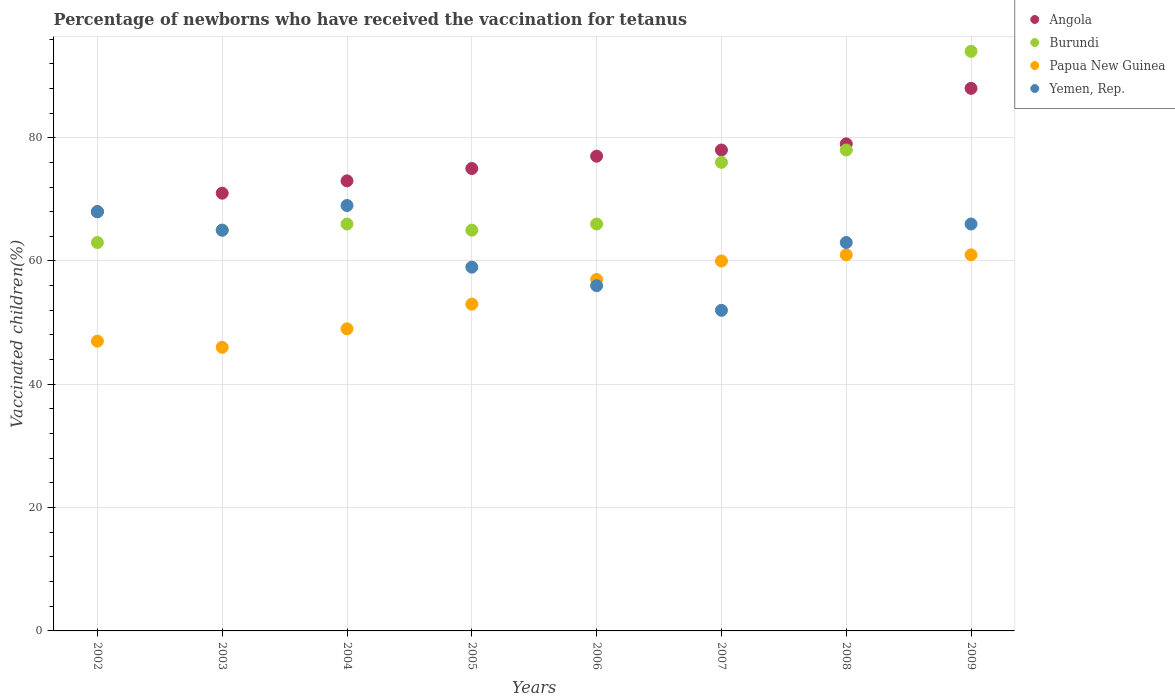Is the number of dotlines equal to the number of legend labels?
Provide a short and direct response. Yes. What is the percentage of vaccinated children in Papua New Guinea in 2006?
Provide a short and direct response. 57. Across all years, what is the maximum percentage of vaccinated children in Yemen, Rep.?
Ensure brevity in your answer.  69. Across all years, what is the minimum percentage of vaccinated children in Papua New Guinea?
Offer a very short reply. 46. What is the total percentage of vaccinated children in Yemen, Rep. in the graph?
Offer a terse response. 498. What is the difference between the percentage of vaccinated children in Angola in 2003 and that in 2004?
Make the answer very short. -2. What is the average percentage of vaccinated children in Burundi per year?
Provide a succinct answer. 71.62. In how many years, is the percentage of vaccinated children in Papua New Guinea greater than 4 %?
Provide a succinct answer. 8. What is the ratio of the percentage of vaccinated children in Angola in 2002 to that in 2008?
Ensure brevity in your answer.  0.86. Is the percentage of vaccinated children in Angola in 2003 less than that in 2004?
Provide a succinct answer. Yes. In how many years, is the percentage of vaccinated children in Burundi greater than the average percentage of vaccinated children in Burundi taken over all years?
Make the answer very short. 3. Is it the case that in every year, the sum of the percentage of vaccinated children in Papua New Guinea and percentage of vaccinated children in Yemen, Rep.  is greater than the sum of percentage of vaccinated children in Angola and percentage of vaccinated children in Burundi?
Keep it short and to the point. No. Is the percentage of vaccinated children in Burundi strictly greater than the percentage of vaccinated children in Angola over the years?
Provide a succinct answer. No. How many dotlines are there?
Offer a terse response. 4. Are the values on the major ticks of Y-axis written in scientific E-notation?
Give a very brief answer. No. Does the graph contain any zero values?
Your response must be concise. No. Does the graph contain grids?
Give a very brief answer. Yes. Where does the legend appear in the graph?
Keep it short and to the point. Top right. How are the legend labels stacked?
Your answer should be very brief. Vertical. What is the title of the graph?
Ensure brevity in your answer.  Percentage of newborns who have received the vaccination for tetanus. What is the label or title of the Y-axis?
Provide a short and direct response. Vaccinated children(%). What is the Vaccinated children(%) of Burundi in 2002?
Ensure brevity in your answer.  63. What is the Vaccinated children(%) of Yemen, Rep. in 2002?
Provide a short and direct response. 68. What is the Vaccinated children(%) in Angola in 2003?
Your answer should be compact. 71. What is the Vaccinated children(%) in Yemen, Rep. in 2003?
Keep it short and to the point. 65. What is the Vaccinated children(%) of Angola in 2004?
Ensure brevity in your answer.  73. What is the Vaccinated children(%) in Yemen, Rep. in 2004?
Offer a very short reply. 69. What is the Vaccinated children(%) in Burundi in 2005?
Provide a succinct answer. 65. What is the Vaccinated children(%) of Papua New Guinea in 2005?
Keep it short and to the point. 53. What is the Vaccinated children(%) in Yemen, Rep. in 2005?
Make the answer very short. 59. What is the Vaccinated children(%) of Burundi in 2006?
Offer a terse response. 66. What is the Vaccinated children(%) in Papua New Guinea in 2006?
Offer a terse response. 57. What is the Vaccinated children(%) of Angola in 2007?
Your answer should be compact. 78. What is the Vaccinated children(%) in Burundi in 2007?
Ensure brevity in your answer.  76. What is the Vaccinated children(%) in Yemen, Rep. in 2007?
Offer a very short reply. 52. What is the Vaccinated children(%) of Angola in 2008?
Ensure brevity in your answer.  79. What is the Vaccinated children(%) in Burundi in 2008?
Give a very brief answer. 78. What is the Vaccinated children(%) of Burundi in 2009?
Keep it short and to the point. 94. What is the Vaccinated children(%) of Papua New Guinea in 2009?
Your response must be concise. 61. Across all years, what is the maximum Vaccinated children(%) in Burundi?
Provide a short and direct response. 94. Across all years, what is the maximum Vaccinated children(%) of Papua New Guinea?
Your response must be concise. 61. Across all years, what is the minimum Vaccinated children(%) of Burundi?
Offer a very short reply. 63. Across all years, what is the minimum Vaccinated children(%) in Yemen, Rep.?
Offer a very short reply. 52. What is the total Vaccinated children(%) in Angola in the graph?
Keep it short and to the point. 609. What is the total Vaccinated children(%) of Burundi in the graph?
Offer a terse response. 573. What is the total Vaccinated children(%) in Papua New Guinea in the graph?
Your answer should be very brief. 434. What is the total Vaccinated children(%) of Yemen, Rep. in the graph?
Offer a very short reply. 498. What is the difference between the Vaccinated children(%) of Angola in 2002 and that in 2003?
Offer a very short reply. -3. What is the difference between the Vaccinated children(%) of Angola in 2002 and that in 2004?
Your answer should be very brief. -5. What is the difference between the Vaccinated children(%) of Burundi in 2002 and that in 2004?
Your answer should be compact. -3. What is the difference between the Vaccinated children(%) of Papua New Guinea in 2002 and that in 2005?
Your answer should be very brief. -6. What is the difference between the Vaccinated children(%) of Papua New Guinea in 2002 and that in 2006?
Your response must be concise. -10. What is the difference between the Vaccinated children(%) of Yemen, Rep. in 2002 and that in 2006?
Offer a very short reply. 12. What is the difference between the Vaccinated children(%) of Angola in 2002 and that in 2007?
Make the answer very short. -10. What is the difference between the Vaccinated children(%) of Papua New Guinea in 2002 and that in 2007?
Ensure brevity in your answer.  -13. What is the difference between the Vaccinated children(%) of Angola in 2002 and that in 2008?
Your response must be concise. -11. What is the difference between the Vaccinated children(%) of Angola in 2002 and that in 2009?
Make the answer very short. -20. What is the difference between the Vaccinated children(%) of Burundi in 2002 and that in 2009?
Keep it short and to the point. -31. What is the difference between the Vaccinated children(%) in Papua New Guinea in 2002 and that in 2009?
Provide a succinct answer. -14. What is the difference between the Vaccinated children(%) in Burundi in 2003 and that in 2004?
Keep it short and to the point. -1. What is the difference between the Vaccinated children(%) of Papua New Guinea in 2003 and that in 2004?
Make the answer very short. -3. What is the difference between the Vaccinated children(%) in Burundi in 2003 and that in 2005?
Give a very brief answer. 0. What is the difference between the Vaccinated children(%) of Yemen, Rep. in 2003 and that in 2005?
Ensure brevity in your answer.  6. What is the difference between the Vaccinated children(%) of Angola in 2003 and that in 2006?
Make the answer very short. -6. What is the difference between the Vaccinated children(%) of Burundi in 2003 and that in 2007?
Ensure brevity in your answer.  -11. What is the difference between the Vaccinated children(%) of Yemen, Rep. in 2003 and that in 2007?
Keep it short and to the point. 13. What is the difference between the Vaccinated children(%) in Angola in 2003 and that in 2008?
Your response must be concise. -8. What is the difference between the Vaccinated children(%) in Burundi in 2003 and that in 2008?
Your response must be concise. -13. What is the difference between the Vaccinated children(%) of Yemen, Rep. in 2003 and that in 2008?
Your response must be concise. 2. What is the difference between the Vaccinated children(%) in Angola in 2004 and that in 2005?
Your answer should be very brief. -2. What is the difference between the Vaccinated children(%) of Burundi in 2004 and that in 2005?
Your answer should be compact. 1. What is the difference between the Vaccinated children(%) of Angola in 2004 and that in 2006?
Your answer should be compact. -4. What is the difference between the Vaccinated children(%) of Burundi in 2004 and that in 2006?
Provide a succinct answer. 0. What is the difference between the Vaccinated children(%) of Papua New Guinea in 2004 and that in 2006?
Your answer should be very brief. -8. What is the difference between the Vaccinated children(%) of Yemen, Rep. in 2004 and that in 2006?
Your answer should be very brief. 13. What is the difference between the Vaccinated children(%) of Papua New Guinea in 2004 and that in 2007?
Your answer should be very brief. -11. What is the difference between the Vaccinated children(%) in Yemen, Rep. in 2004 and that in 2007?
Provide a short and direct response. 17. What is the difference between the Vaccinated children(%) of Angola in 2004 and that in 2008?
Your answer should be very brief. -6. What is the difference between the Vaccinated children(%) in Burundi in 2004 and that in 2009?
Ensure brevity in your answer.  -28. What is the difference between the Vaccinated children(%) of Angola in 2005 and that in 2006?
Offer a very short reply. -2. What is the difference between the Vaccinated children(%) of Burundi in 2005 and that in 2006?
Provide a succinct answer. -1. What is the difference between the Vaccinated children(%) of Papua New Guinea in 2005 and that in 2006?
Your answer should be compact. -4. What is the difference between the Vaccinated children(%) in Yemen, Rep. in 2005 and that in 2006?
Your response must be concise. 3. What is the difference between the Vaccinated children(%) of Angola in 2005 and that in 2007?
Provide a short and direct response. -3. What is the difference between the Vaccinated children(%) of Papua New Guinea in 2005 and that in 2007?
Your answer should be compact. -7. What is the difference between the Vaccinated children(%) in Yemen, Rep. in 2005 and that in 2007?
Make the answer very short. 7. What is the difference between the Vaccinated children(%) of Papua New Guinea in 2005 and that in 2009?
Your answer should be compact. -8. What is the difference between the Vaccinated children(%) in Burundi in 2006 and that in 2007?
Your answer should be very brief. -10. What is the difference between the Vaccinated children(%) in Papua New Guinea in 2006 and that in 2007?
Offer a terse response. -3. What is the difference between the Vaccinated children(%) in Yemen, Rep. in 2006 and that in 2007?
Your answer should be very brief. 4. What is the difference between the Vaccinated children(%) of Papua New Guinea in 2006 and that in 2009?
Give a very brief answer. -4. What is the difference between the Vaccinated children(%) of Yemen, Rep. in 2006 and that in 2009?
Provide a short and direct response. -10. What is the difference between the Vaccinated children(%) of Angola in 2007 and that in 2008?
Make the answer very short. -1. What is the difference between the Vaccinated children(%) in Burundi in 2007 and that in 2008?
Provide a succinct answer. -2. What is the difference between the Vaccinated children(%) in Papua New Guinea in 2007 and that in 2008?
Your answer should be compact. -1. What is the difference between the Vaccinated children(%) of Yemen, Rep. in 2007 and that in 2008?
Give a very brief answer. -11. What is the difference between the Vaccinated children(%) in Burundi in 2007 and that in 2009?
Your answer should be very brief. -18. What is the difference between the Vaccinated children(%) in Papua New Guinea in 2007 and that in 2009?
Offer a very short reply. -1. What is the difference between the Vaccinated children(%) in Burundi in 2008 and that in 2009?
Offer a very short reply. -16. What is the difference between the Vaccinated children(%) in Yemen, Rep. in 2008 and that in 2009?
Give a very brief answer. -3. What is the difference between the Vaccinated children(%) of Angola in 2002 and the Vaccinated children(%) of Burundi in 2003?
Offer a very short reply. 3. What is the difference between the Vaccinated children(%) of Angola in 2002 and the Vaccinated children(%) of Papua New Guinea in 2003?
Make the answer very short. 22. What is the difference between the Vaccinated children(%) of Angola in 2002 and the Vaccinated children(%) of Yemen, Rep. in 2003?
Give a very brief answer. 3. What is the difference between the Vaccinated children(%) of Angola in 2002 and the Vaccinated children(%) of Burundi in 2004?
Your answer should be compact. 2. What is the difference between the Vaccinated children(%) of Angola in 2002 and the Vaccinated children(%) of Papua New Guinea in 2004?
Make the answer very short. 19. What is the difference between the Vaccinated children(%) in Burundi in 2002 and the Vaccinated children(%) in Yemen, Rep. in 2004?
Provide a succinct answer. -6. What is the difference between the Vaccinated children(%) in Angola in 2002 and the Vaccinated children(%) in Burundi in 2005?
Your response must be concise. 3. What is the difference between the Vaccinated children(%) in Angola in 2002 and the Vaccinated children(%) in Papua New Guinea in 2005?
Provide a short and direct response. 15. What is the difference between the Vaccinated children(%) in Angola in 2002 and the Vaccinated children(%) in Burundi in 2006?
Provide a succinct answer. 2. What is the difference between the Vaccinated children(%) in Angola in 2002 and the Vaccinated children(%) in Papua New Guinea in 2006?
Provide a succinct answer. 11. What is the difference between the Vaccinated children(%) of Angola in 2002 and the Vaccinated children(%) of Yemen, Rep. in 2006?
Your answer should be very brief. 12. What is the difference between the Vaccinated children(%) of Burundi in 2002 and the Vaccinated children(%) of Papua New Guinea in 2006?
Give a very brief answer. 6. What is the difference between the Vaccinated children(%) of Angola in 2002 and the Vaccinated children(%) of Burundi in 2007?
Make the answer very short. -8. What is the difference between the Vaccinated children(%) in Burundi in 2002 and the Vaccinated children(%) in Papua New Guinea in 2007?
Make the answer very short. 3. What is the difference between the Vaccinated children(%) in Burundi in 2002 and the Vaccinated children(%) in Yemen, Rep. in 2007?
Offer a terse response. 11. What is the difference between the Vaccinated children(%) in Papua New Guinea in 2002 and the Vaccinated children(%) in Yemen, Rep. in 2007?
Keep it short and to the point. -5. What is the difference between the Vaccinated children(%) of Angola in 2002 and the Vaccinated children(%) of Papua New Guinea in 2008?
Your answer should be very brief. 7. What is the difference between the Vaccinated children(%) in Angola in 2002 and the Vaccinated children(%) in Yemen, Rep. in 2008?
Make the answer very short. 5. What is the difference between the Vaccinated children(%) in Burundi in 2002 and the Vaccinated children(%) in Yemen, Rep. in 2008?
Provide a succinct answer. 0. What is the difference between the Vaccinated children(%) of Angola in 2002 and the Vaccinated children(%) of Burundi in 2009?
Provide a short and direct response. -26. What is the difference between the Vaccinated children(%) in Angola in 2002 and the Vaccinated children(%) in Yemen, Rep. in 2009?
Your answer should be compact. 2. What is the difference between the Vaccinated children(%) in Papua New Guinea in 2002 and the Vaccinated children(%) in Yemen, Rep. in 2009?
Ensure brevity in your answer.  -19. What is the difference between the Vaccinated children(%) in Angola in 2003 and the Vaccinated children(%) in Burundi in 2004?
Your answer should be very brief. 5. What is the difference between the Vaccinated children(%) in Burundi in 2003 and the Vaccinated children(%) in Papua New Guinea in 2004?
Give a very brief answer. 16. What is the difference between the Vaccinated children(%) in Angola in 2003 and the Vaccinated children(%) in Yemen, Rep. in 2005?
Your answer should be compact. 12. What is the difference between the Vaccinated children(%) of Angola in 2003 and the Vaccinated children(%) of Burundi in 2006?
Your answer should be very brief. 5. What is the difference between the Vaccinated children(%) of Angola in 2003 and the Vaccinated children(%) of Papua New Guinea in 2006?
Provide a short and direct response. 14. What is the difference between the Vaccinated children(%) in Angola in 2003 and the Vaccinated children(%) in Yemen, Rep. in 2006?
Provide a succinct answer. 15. What is the difference between the Vaccinated children(%) in Burundi in 2003 and the Vaccinated children(%) in Papua New Guinea in 2006?
Keep it short and to the point. 8. What is the difference between the Vaccinated children(%) of Burundi in 2003 and the Vaccinated children(%) of Yemen, Rep. in 2006?
Your answer should be very brief. 9. What is the difference between the Vaccinated children(%) in Papua New Guinea in 2003 and the Vaccinated children(%) in Yemen, Rep. in 2006?
Offer a very short reply. -10. What is the difference between the Vaccinated children(%) of Angola in 2003 and the Vaccinated children(%) of Burundi in 2007?
Your response must be concise. -5. What is the difference between the Vaccinated children(%) of Angola in 2003 and the Vaccinated children(%) of Burundi in 2008?
Ensure brevity in your answer.  -7. What is the difference between the Vaccinated children(%) of Angola in 2003 and the Vaccinated children(%) of Yemen, Rep. in 2008?
Offer a very short reply. 8. What is the difference between the Vaccinated children(%) in Burundi in 2003 and the Vaccinated children(%) in Papua New Guinea in 2008?
Your answer should be compact. 4. What is the difference between the Vaccinated children(%) of Angola in 2003 and the Vaccinated children(%) of Burundi in 2009?
Keep it short and to the point. -23. What is the difference between the Vaccinated children(%) of Angola in 2003 and the Vaccinated children(%) of Papua New Guinea in 2009?
Give a very brief answer. 10. What is the difference between the Vaccinated children(%) in Angola in 2003 and the Vaccinated children(%) in Yemen, Rep. in 2009?
Your response must be concise. 5. What is the difference between the Vaccinated children(%) in Burundi in 2003 and the Vaccinated children(%) in Papua New Guinea in 2009?
Ensure brevity in your answer.  4. What is the difference between the Vaccinated children(%) of Burundi in 2003 and the Vaccinated children(%) of Yemen, Rep. in 2009?
Provide a short and direct response. -1. What is the difference between the Vaccinated children(%) in Angola in 2004 and the Vaccinated children(%) in Papua New Guinea in 2005?
Give a very brief answer. 20. What is the difference between the Vaccinated children(%) in Burundi in 2004 and the Vaccinated children(%) in Papua New Guinea in 2005?
Offer a very short reply. 13. What is the difference between the Vaccinated children(%) of Angola in 2004 and the Vaccinated children(%) of Burundi in 2006?
Ensure brevity in your answer.  7. What is the difference between the Vaccinated children(%) in Angola in 2004 and the Vaccinated children(%) in Papua New Guinea in 2006?
Your answer should be very brief. 16. What is the difference between the Vaccinated children(%) in Angola in 2004 and the Vaccinated children(%) in Yemen, Rep. in 2006?
Make the answer very short. 17. What is the difference between the Vaccinated children(%) in Burundi in 2004 and the Vaccinated children(%) in Papua New Guinea in 2006?
Your answer should be very brief. 9. What is the difference between the Vaccinated children(%) in Papua New Guinea in 2004 and the Vaccinated children(%) in Yemen, Rep. in 2006?
Ensure brevity in your answer.  -7. What is the difference between the Vaccinated children(%) in Angola in 2004 and the Vaccinated children(%) in Yemen, Rep. in 2007?
Provide a short and direct response. 21. What is the difference between the Vaccinated children(%) of Burundi in 2004 and the Vaccinated children(%) of Papua New Guinea in 2007?
Keep it short and to the point. 6. What is the difference between the Vaccinated children(%) in Angola in 2004 and the Vaccinated children(%) in Burundi in 2008?
Give a very brief answer. -5. What is the difference between the Vaccinated children(%) of Angola in 2004 and the Vaccinated children(%) of Papua New Guinea in 2008?
Keep it short and to the point. 12. What is the difference between the Vaccinated children(%) in Burundi in 2004 and the Vaccinated children(%) in Papua New Guinea in 2008?
Your answer should be very brief. 5. What is the difference between the Vaccinated children(%) of Angola in 2004 and the Vaccinated children(%) of Burundi in 2009?
Give a very brief answer. -21. What is the difference between the Vaccinated children(%) of Angola in 2004 and the Vaccinated children(%) of Papua New Guinea in 2009?
Your answer should be very brief. 12. What is the difference between the Vaccinated children(%) in Papua New Guinea in 2004 and the Vaccinated children(%) in Yemen, Rep. in 2009?
Your response must be concise. -17. What is the difference between the Vaccinated children(%) in Angola in 2005 and the Vaccinated children(%) in Burundi in 2006?
Ensure brevity in your answer.  9. What is the difference between the Vaccinated children(%) in Angola in 2005 and the Vaccinated children(%) in Yemen, Rep. in 2006?
Provide a short and direct response. 19. What is the difference between the Vaccinated children(%) of Burundi in 2005 and the Vaccinated children(%) of Papua New Guinea in 2006?
Ensure brevity in your answer.  8. What is the difference between the Vaccinated children(%) in Burundi in 2005 and the Vaccinated children(%) in Yemen, Rep. in 2006?
Give a very brief answer. 9. What is the difference between the Vaccinated children(%) in Papua New Guinea in 2005 and the Vaccinated children(%) in Yemen, Rep. in 2006?
Make the answer very short. -3. What is the difference between the Vaccinated children(%) in Angola in 2005 and the Vaccinated children(%) in Yemen, Rep. in 2007?
Give a very brief answer. 23. What is the difference between the Vaccinated children(%) in Burundi in 2005 and the Vaccinated children(%) in Papua New Guinea in 2007?
Your response must be concise. 5. What is the difference between the Vaccinated children(%) in Angola in 2005 and the Vaccinated children(%) in Burundi in 2008?
Make the answer very short. -3. What is the difference between the Vaccinated children(%) of Angola in 2005 and the Vaccinated children(%) of Papua New Guinea in 2008?
Give a very brief answer. 14. What is the difference between the Vaccinated children(%) in Burundi in 2005 and the Vaccinated children(%) in Yemen, Rep. in 2008?
Your response must be concise. 2. What is the difference between the Vaccinated children(%) in Burundi in 2005 and the Vaccinated children(%) in Yemen, Rep. in 2009?
Your answer should be very brief. -1. What is the difference between the Vaccinated children(%) in Angola in 2006 and the Vaccinated children(%) in Burundi in 2007?
Make the answer very short. 1. What is the difference between the Vaccinated children(%) of Angola in 2006 and the Vaccinated children(%) of Papua New Guinea in 2007?
Provide a short and direct response. 17. What is the difference between the Vaccinated children(%) in Burundi in 2006 and the Vaccinated children(%) in Yemen, Rep. in 2007?
Offer a terse response. 14. What is the difference between the Vaccinated children(%) of Angola in 2006 and the Vaccinated children(%) of Yemen, Rep. in 2009?
Give a very brief answer. 11. What is the difference between the Vaccinated children(%) in Angola in 2007 and the Vaccinated children(%) in Burundi in 2008?
Make the answer very short. 0. What is the difference between the Vaccinated children(%) of Burundi in 2007 and the Vaccinated children(%) of Papua New Guinea in 2008?
Your response must be concise. 15. What is the difference between the Vaccinated children(%) in Papua New Guinea in 2007 and the Vaccinated children(%) in Yemen, Rep. in 2008?
Provide a short and direct response. -3. What is the difference between the Vaccinated children(%) in Angola in 2007 and the Vaccinated children(%) in Burundi in 2009?
Your answer should be compact. -16. What is the difference between the Vaccinated children(%) of Angola in 2007 and the Vaccinated children(%) of Papua New Guinea in 2009?
Provide a succinct answer. 17. What is the difference between the Vaccinated children(%) of Angola in 2007 and the Vaccinated children(%) of Yemen, Rep. in 2009?
Offer a terse response. 12. What is the difference between the Vaccinated children(%) of Burundi in 2007 and the Vaccinated children(%) of Yemen, Rep. in 2009?
Make the answer very short. 10. What is the difference between the Vaccinated children(%) in Papua New Guinea in 2007 and the Vaccinated children(%) in Yemen, Rep. in 2009?
Your answer should be compact. -6. What is the difference between the Vaccinated children(%) in Angola in 2008 and the Vaccinated children(%) in Burundi in 2009?
Ensure brevity in your answer.  -15. What is the difference between the Vaccinated children(%) in Angola in 2008 and the Vaccinated children(%) in Papua New Guinea in 2009?
Make the answer very short. 18. What is the difference between the Vaccinated children(%) in Angola in 2008 and the Vaccinated children(%) in Yemen, Rep. in 2009?
Your answer should be compact. 13. What is the difference between the Vaccinated children(%) in Burundi in 2008 and the Vaccinated children(%) in Papua New Guinea in 2009?
Offer a very short reply. 17. What is the difference between the Vaccinated children(%) of Burundi in 2008 and the Vaccinated children(%) of Yemen, Rep. in 2009?
Your response must be concise. 12. What is the average Vaccinated children(%) in Angola per year?
Keep it short and to the point. 76.12. What is the average Vaccinated children(%) of Burundi per year?
Provide a succinct answer. 71.62. What is the average Vaccinated children(%) in Papua New Guinea per year?
Your answer should be compact. 54.25. What is the average Vaccinated children(%) in Yemen, Rep. per year?
Keep it short and to the point. 62.25. In the year 2002, what is the difference between the Vaccinated children(%) in Angola and Vaccinated children(%) in Burundi?
Offer a terse response. 5. In the year 2002, what is the difference between the Vaccinated children(%) in Angola and Vaccinated children(%) in Papua New Guinea?
Provide a succinct answer. 21. In the year 2002, what is the difference between the Vaccinated children(%) in Angola and Vaccinated children(%) in Yemen, Rep.?
Ensure brevity in your answer.  0. In the year 2002, what is the difference between the Vaccinated children(%) in Burundi and Vaccinated children(%) in Yemen, Rep.?
Your answer should be compact. -5. In the year 2002, what is the difference between the Vaccinated children(%) in Papua New Guinea and Vaccinated children(%) in Yemen, Rep.?
Keep it short and to the point. -21. In the year 2003, what is the difference between the Vaccinated children(%) in Angola and Vaccinated children(%) in Papua New Guinea?
Provide a short and direct response. 25. In the year 2003, what is the difference between the Vaccinated children(%) of Angola and Vaccinated children(%) of Yemen, Rep.?
Provide a short and direct response. 6. In the year 2004, what is the difference between the Vaccinated children(%) in Angola and Vaccinated children(%) in Burundi?
Ensure brevity in your answer.  7. In the year 2004, what is the difference between the Vaccinated children(%) in Angola and Vaccinated children(%) in Yemen, Rep.?
Keep it short and to the point. 4. In the year 2005, what is the difference between the Vaccinated children(%) in Angola and Vaccinated children(%) in Yemen, Rep.?
Your response must be concise. 16. In the year 2005, what is the difference between the Vaccinated children(%) in Burundi and Vaccinated children(%) in Papua New Guinea?
Keep it short and to the point. 12. In the year 2006, what is the difference between the Vaccinated children(%) in Angola and Vaccinated children(%) in Burundi?
Your answer should be very brief. 11. In the year 2006, what is the difference between the Vaccinated children(%) of Burundi and Vaccinated children(%) of Papua New Guinea?
Provide a succinct answer. 9. In the year 2006, what is the difference between the Vaccinated children(%) of Burundi and Vaccinated children(%) of Yemen, Rep.?
Keep it short and to the point. 10. In the year 2006, what is the difference between the Vaccinated children(%) of Papua New Guinea and Vaccinated children(%) of Yemen, Rep.?
Offer a very short reply. 1. In the year 2007, what is the difference between the Vaccinated children(%) in Angola and Vaccinated children(%) in Burundi?
Make the answer very short. 2. In the year 2007, what is the difference between the Vaccinated children(%) of Burundi and Vaccinated children(%) of Papua New Guinea?
Your answer should be compact. 16. In the year 2007, what is the difference between the Vaccinated children(%) in Burundi and Vaccinated children(%) in Yemen, Rep.?
Offer a terse response. 24. In the year 2008, what is the difference between the Vaccinated children(%) in Angola and Vaccinated children(%) in Burundi?
Your response must be concise. 1. In the year 2008, what is the difference between the Vaccinated children(%) of Angola and Vaccinated children(%) of Papua New Guinea?
Your response must be concise. 18. In the year 2008, what is the difference between the Vaccinated children(%) in Burundi and Vaccinated children(%) in Papua New Guinea?
Your answer should be compact. 17. In the year 2008, what is the difference between the Vaccinated children(%) in Papua New Guinea and Vaccinated children(%) in Yemen, Rep.?
Provide a succinct answer. -2. In the year 2009, what is the difference between the Vaccinated children(%) in Angola and Vaccinated children(%) in Burundi?
Provide a succinct answer. -6. In the year 2009, what is the difference between the Vaccinated children(%) in Burundi and Vaccinated children(%) in Papua New Guinea?
Offer a very short reply. 33. In the year 2009, what is the difference between the Vaccinated children(%) in Papua New Guinea and Vaccinated children(%) in Yemen, Rep.?
Your answer should be compact. -5. What is the ratio of the Vaccinated children(%) in Angola in 2002 to that in 2003?
Offer a terse response. 0.96. What is the ratio of the Vaccinated children(%) in Burundi in 2002 to that in 2003?
Give a very brief answer. 0.97. What is the ratio of the Vaccinated children(%) of Papua New Guinea in 2002 to that in 2003?
Your response must be concise. 1.02. What is the ratio of the Vaccinated children(%) of Yemen, Rep. in 2002 to that in 2003?
Ensure brevity in your answer.  1.05. What is the ratio of the Vaccinated children(%) in Angola in 2002 to that in 2004?
Provide a short and direct response. 0.93. What is the ratio of the Vaccinated children(%) of Burundi in 2002 to that in 2004?
Ensure brevity in your answer.  0.95. What is the ratio of the Vaccinated children(%) of Papua New Guinea in 2002 to that in 2004?
Provide a succinct answer. 0.96. What is the ratio of the Vaccinated children(%) of Yemen, Rep. in 2002 to that in 2004?
Offer a terse response. 0.99. What is the ratio of the Vaccinated children(%) in Angola in 2002 to that in 2005?
Your response must be concise. 0.91. What is the ratio of the Vaccinated children(%) in Burundi in 2002 to that in 2005?
Provide a succinct answer. 0.97. What is the ratio of the Vaccinated children(%) of Papua New Guinea in 2002 to that in 2005?
Offer a terse response. 0.89. What is the ratio of the Vaccinated children(%) in Yemen, Rep. in 2002 to that in 2005?
Your answer should be compact. 1.15. What is the ratio of the Vaccinated children(%) of Angola in 2002 to that in 2006?
Offer a very short reply. 0.88. What is the ratio of the Vaccinated children(%) of Burundi in 2002 to that in 2006?
Ensure brevity in your answer.  0.95. What is the ratio of the Vaccinated children(%) of Papua New Guinea in 2002 to that in 2006?
Your answer should be compact. 0.82. What is the ratio of the Vaccinated children(%) of Yemen, Rep. in 2002 to that in 2006?
Make the answer very short. 1.21. What is the ratio of the Vaccinated children(%) of Angola in 2002 to that in 2007?
Provide a succinct answer. 0.87. What is the ratio of the Vaccinated children(%) of Burundi in 2002 to that in 2007?
Offer a terse response. 0.83. What is the ratio of the Vaccinated children(%) in Papua New Guinea in 2002 to that in 2007?
Offer a terse response. 0.78. What is the ratio of the Vaccinated children(%) of Yemen, Rep. in 2002 to that in 2007?
Keep it short and to the point. 1.31. What is the ratio of the Vaccinated children(%) of Angola in 2002 to that in 2008?
Provide a short and direct response. 0.86. What is the ratio of the Vaccinated children(%) of Burundi in 2002 to that in 2008?
Provide a succinct answer. 0.81. What is the ratio of the Vaccinated children(%) in Papua New Guinea in 2002 to that in 2008?
Make the answer very short. 0.77. What is the ratio of the Vaccinated children(%) in Yemen, Rep. in 2002 to that in 2008?
Give a very brief answer. 1.08. What is the ratio of the Vaccinated children(%) of Angola in 2002 to that in 2009?
Your answer should be compact. 0.77. What is the ratio of the Vaccinated children(%) in Burundi in 2002 to that in 2009?
Make the answer very short. 0.67. What is the ratio of the Vaccinated children(%) of Papua New Guinea in 2002 to that in 2009?
Give a very brief answer. 0.77. What is the ratio of the Vaccinated children(%) of Yemen, Rep. in 2002 to that in 2009?
Offer a terse response. 1.03. What is the ratio of the Vaccinated children(%) in Angola in 2003 to that in 2004?
Offer a very short reply. 0.97. What is the ratio of the Vaccinated children(%) of Burundi in 2003 to that in 2004?
Make the answer very short. 0.98. What is the ratio of the Vaccinated children(%) in Papua New Guinea in 2003 to that in 2004?
Offer a very short reply. 0.94. What is the ratio of the Vaccinated children(%) of Yemen, Rep. in 2003 to that in 2004?
Make the answer very short. 0.94. What is the ratio of the Vaccinated children(%) in Angola in 2003 to that in 2005?
Ensure brevity in your answer.  0.95. What is the ratio of the Vaccinated children(%) of Papua New Guinea in 2003 to that in 2005?
Offer a terse response. 0.87. What is the ratio of the Vaccinated children(%) of Yemen, Rep. in 2003 to that in 2005?
Make the answer very short. 1.1. What is the ratio of the Vaccinated children(%) in Angola in 2003 to that in 2006?
Ensure brevity in your answer.  0.92. What is the ratio of the Vaccinated children(%) of Papua New Guinea in 2003 to that in 2006?
Give a very brief answer. 0.81. What is the ratio of the Vaccinated children(%) in Yemen, Rep. in 2003 to that in 2006?
Offer a very short reply. 1.16. What is the ratio of the Vaccinated children(%) of Angola in 2003 to that in 2007?
Keep it short and to the point. 0.91. What is the ratio of the Vaccinated children(%) of Burundi in 2003 to that in 2007?
Your answer should be very brief. 0.86. What is the ratio of the Vaccinated children(%) in Papua New Guinea in 2003 to that in 2007?
Offer a very short reply. 0.77. What is the ratio of the Vaccinated children(%) in Angola in 2003 to that in 2008?
Make the answer very short. 0.9. What is the ratio of the Vaccinated children(%) of Papua New Guinea in 2003 to that in 2008?
Keep it short and to the point. 0.75. What is the ratio of the Vaccinated children(%) in Yemen, Rep. in 2003 to that in 2008?
Your answer should be compact. 1.03. What is the ratio of the Vaccinated children(%) of Angola in 2003 to that in 2009?
Offer a very short reply. 0.81. What is the ratio of the Vaccinated children(%) in Burundi in 2003 to that in 2009?
Offer a very short reply. 0.69. What is the ratio of the Vaccinated children(%) of Papua New Guinea in 2003 to that in 2009?
Ensure brevity in your answer.  0.75. What is the ratio of the Vaccinated children(%) in Angola in 2004 to that in 2005?
Provide a short and direct response. 0.97. What is the ratio of the Vaccinated children(%) of Burundi in 2004 to that in 2005?
Offer a terse response. 1.02. What is the ratio of the Vaccinated children(%) in Papua New Guinea in 2004 to that in 2005?
Your answer should be very brief. 0.92. What is the ratio of the Vaccinated children(%) in Yemen, Rep. in 2004 to that in 2005?
Make the answer very short. 1.17. What is the ratio of the Vaccinated children(%) in Angola in 2004 to that in 2006?
Your response must be concise. 0.95. What is the ratio of the Vaccinated children(%) in Burundi in 2004 to that in 2006?
Your response must be concise. 1. What is the ratio of the Vaccinated children(%) of Papua New Guinea in 2004 to that in 2006?
Ensure brevity in your answer.  0.86. What is the ratio of the Vaccinated children(%) in Yemen, Rep. in 2004 to that in 2006?
Your answer should be very brief. 1.23. What is the ratio of the Vaccinated children(%) of Angola in 2004 to that in 2007?
Keep it short and to the point. 0.94. What is the ratio of the Vaccinated children(%) of Burundi in 2004 to that in 2007?
Your answer should be compact. 0.87. What is the ratio of the Vaccinated children(%) in Papua New Guinea in 2004 to that in 2007?
Your answer should be compact. 0.82. What is the ratio of the Vaccinated children(%) of Yemen, Rep. in 2004 to that in 2007?
Your answer should be compact. 1.33. What is the ratio of the Vaccinated children(%) of Angola in 2004 to that in 2008?
Provide a succinct answer. 0.92. What is the ratio of the Vaccinated children(%) of Burundi in 2004 to that in 2008?
Provide a succinct answer. 0.85. What is the ratio of the Vaccinated children(%) in Papua New Guinea in 2004 to that in 2008?
Give a very brief answer. 0.8. What is the ratio of the Vaccinated children(%) in Yemen, Rep. in 2004 to that in 2008?
Provide a short and direct response. 1.1. What is the ratio of the Vaccinated children(%) in Angola in 2004 to that in 2009?
Give a very brief answer. 0.83. What is the ratio of the Vaccinated children(%) of Burundi in 2004 to that in 2009?
Keep it short and to the point. 0.7. What is the ratio of the Vaccinated children(%) of Papua New Guinea in 2004 to that in 2009?
Offer a terse response. 0.8. What is the ratio of the Vaccinated children(%) in Yemen, Rep. in 2004 to that in 2009?
Provide a short and direct response. 1.05. What is the ratio of the Vaccinated children(%) in Angola in 2005 to that in 2006?
Provide a succinct answer. 0.97. What is the ratio of the Vaccinated children(%) in Burundi in 2005 to that in 2006?
Offer a terse response. 0.98. What is the ratio of the Vaccinated children(%) of Papua New Guinea in 2005 to that in 2006?
Your response must be concise. 0.93. What is the ratio of the Vaccinated children(%) in Yemen, Rep. in 2005 to that in 2006?
Your answer should be compact. 1.05. What is the ratio of the Vaccinated children(%) in Angola in 2005 to that in 2007?
Keep it short and to the point. 0.96. What is the ratio of the Vaccinated children(%) in Burundi in 2005 to that in 2007?
Keep it short and to the point. 0.86. What is the ratio of the Vaccinated children(%) of Papua New Guinea in 2005 to that in 2007?
Offer a terse response. 0.88. What is the ratio of the Vaccinated children(%) of Yemen, Rep. in 2005 to that in 2007?
Offer a very short reply. 1.13. What is the ratio of the Vaccinated children(%) of Angola in 2005 to that in 2008?
Provide a succinct answer. 0.95. What is the ratio of the Vaccinated children(%) of Burundi in 2005 to that in 2008?
Make the answer very short. 0.83. What is the ratio of the Vaccinated children(%) of Papua New Guinea in 2005 to that in 2008?
Offer a very short reply. 0.87. What is the ratio of the Vaccinated children(%) of Yemen, Rep. in 2005 to that in 2008?
Make the answer very short. 0.94. What is the ratio of the Vaccinated children(%) in Angola in 2005 to that in 2009?
Your answer should be compact. 0.85. What is the ratio of the Vaccinated children(%) of Burundi in 2005 to that in 2009?
Provide a succinct answer. 0.69. What is the ratio of the Vaccinated children(%) of Papua New Guinea in 2005 to that in 2009?
Your response must be concise. 0.87. What is the ratio of the Vaccinated children(%) of Yemen, Rep. in 2005 to that in 2009?
Your answer should be very brief. 0.89. What is the ratio of the Vaccinated children(%) in Angola in 2006 to that in 2007?
Your answer should be very brief. 0.99. What is the ratio of the Vaccinated children(%) of Burundi in 2006 to that in 2007?
Offer a terse response. 0.87. What is the ratio of the Vaccinated children(%) in Papua New Guinea in 2006 to that in 2007?
Keep it short and to the point. 0.95. What is the ratio of the Vaccinated children(%) in Angola in 2006 to that in 2008?
Provide a short and direct response. 0.97. What is the ratio of the Vaccinated children(%) of Burundi in 2006 to that in 2008?
Offer a very short reply. 0.85. What is the ratio of the Vaccinated children(%) of Papua New Guinea in 2006 to that in 2008?
Make the answer very short. 0.93. What is the ratio of the Vaccinated children(%) of Burundi in 2006 to that in 2009?
Offer a terse response. 0.7. What is the ratio of the Vaccinated children(%) of Papua New Guinea in 2006 to that in 2009?
Ensure brevity in your answer.  0.93. What is the ratio of the Vaccinated children(%) of Yemen, Rep. in 2006 to that in 2009?
Give a very brief answer. 0.85. What is the ratio of the Vaccinated children(%) of Angola in 2007 to that in 2008?
Offer a terse response. 0.99. What is the ratio of the Vaccinated children(%) of Burundi in 2007 to that in 2008?
Make the answer very short. 0.97. What is the ratio of the Vaccinated children(%) in Papua New Guinea in 2007 to that in 2008?
Give a very brief answer. 0.98. What is the ratio of the Vaccinated children(%) of Yemen, Rep. in 2007 to that in 2008?
Your answer should be compact. 0.83. What is the ratio of the Vaccinated children(%) in Angola in 2007 to that in 2009?
Offer a very short reply. 0.89. What is the ratio of the Vaccinated children(%) of Burundi in 2007 to that in 2009?
Your answer should be compact. 0.81. What is the ratio of the Vaccinated children(%) in Papua New Guinea in 2007 to that in 2009?
Your answer should be compact. 0.98. What is the ratio of the Vaccinated children(%) of Yemen, Rep. in 2007 to that in 2009?
Provide a short and direct response. 0.79. What is the ratio of the Vaccinated children(%) of Angola in 2008 to that in 2009?
Provide a short and direct response. 0.9. What is the ratio of the Vaccinated children(%) of Burundi in 2008 to that in 2009?
Keep it short and to the point. 0.83. What is the ratio of the Vaccinated children(%) in Yemen, Rep. in 2008 to that in 2009?
Provide a succinct answer. 0.95. What is the difference between the highest and the second highest Vaccinated children(%) of Angola?
Your answer should be compact. 9. What is the difference between the highest and the second highest Vaccinated children(%) in Burundi?
Provide a short and direct response. 16. What is the difference between the highest and the second highest Vaccinated children(%) in Papua New Guinea?
Your answer should be very brief. 0. What is the difference between the highest and the lowest Vaccinated children(%) of Angola?
Keep it short and to the point. 20. What is the difference between the highest and the lowest Vaccinated children(%) in Burundi?
Your response must be concise. 31. What is the difference between the highest and the lowest Vaccinated children(%) of Papua New Guinea?
Your answer should be compact. 15. What is the difference between the highest and the lowest Vaccinated children(%) in Yemen, Rep.?
Make the answer very short. 17. 